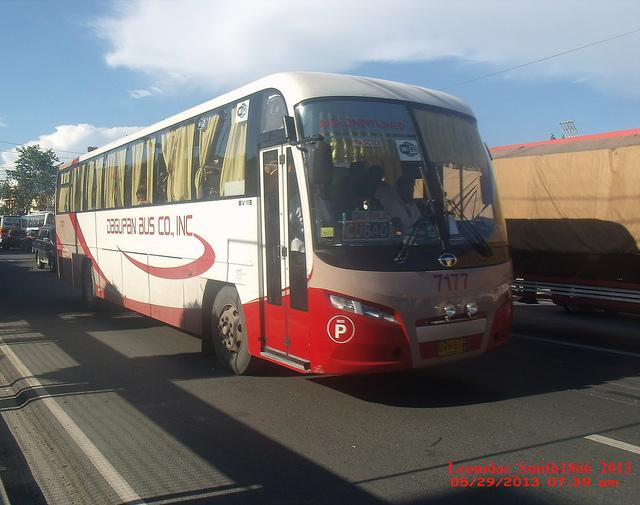Which street lane or lanes is the bus traveling in?

Choices:
A) left lane
B) both lanes
C) right lane
D) neither lane both lanes 